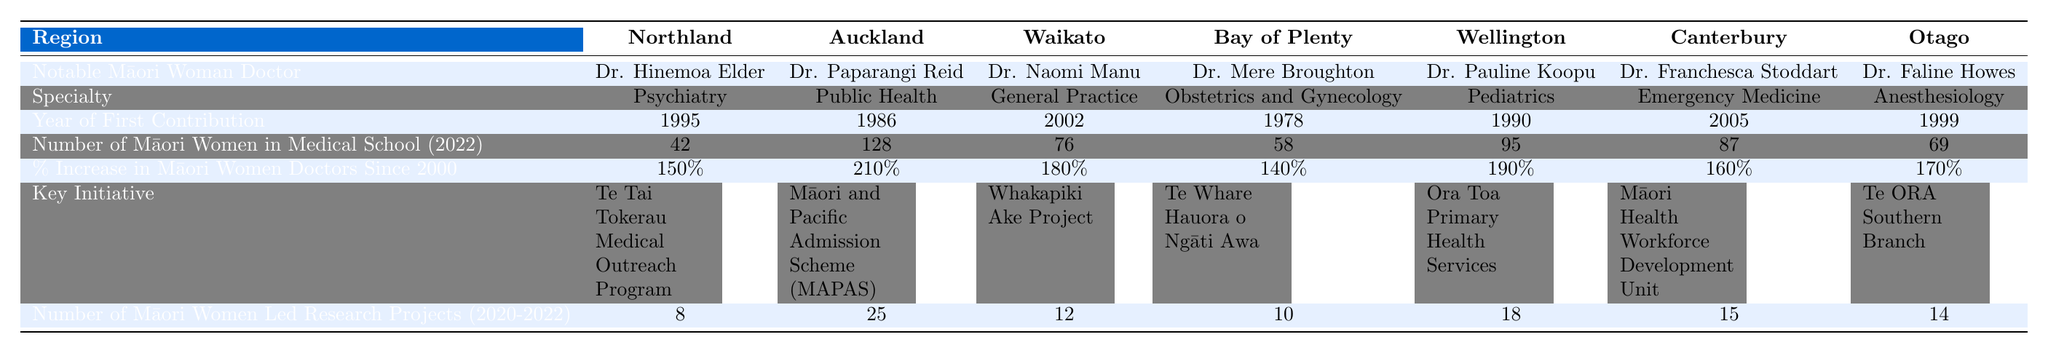What is the specialty of Dr. Faline Howes? According to the table, Dr. Faline Howes is listed under the "Specialty" row in the Otago region, which indicates her specialty is Anesthesiology.
Answer: Anesthesiology Which region has the highest percentage increase in Māori women doctors since 2000? In the table, the Percentage Increase in Māori Women Doctors Since 2000 for each region shows Auckland has the highest at 210%.
Answer: Auckland How many Māori women in medical school were there in Waikato in 2022? The table lists the Number of Māori Women in Medical School (2022) for Waikato, which is 76.
Answer: 76 What is the year of the first contribution of Dr. Mere Broughton? The table indicates that Dr. Mere Broughton's year of first contribution is recorded as 1978 under the relevant row.
Answer: 1978 What is the total number of Māori women led research projects reported from 2020-2022 across all regions? To find the total, we sum the values in the Number of Māori Women Led Research Projects (2020-2022) row: 8 + 25 + 12 + 10 + 18 + 15 + 14 = 102.
Answer: 102 Which region has the lowest number of Māori women in medical school in 2022? By comparing the values in the Number of Māori Women in Medical School (2022) row, Northland has the lowest with 42.
Answer: Northland Is there a notable Māori woman doctor specializing in Pediatrics? Examining the Specialty row, Dr. Pauline Koopu is identified as a notable Māori woman doctor in the specialty of Pediatrics. Thus, the answer is yes.
Answer: Yes How many more Māori women are in medical school in Auckland compared to Northland in 2022? The difference is calculated as the number of Māori women in Auckland (128) minus the number in Northland (42), resulting in 128 - 42 = 86.
Answer: 86 What is the key initiative associated with Dr. Naomi Manu's region? From the table, the key initiative associated with Waikato, where Dr. Naomi Manu is located, is the Whakapiki Ake Project.
Answer: Whakapiki Ake Project If we consider the average number of Māori women led research projects across all regions, what would it be? We can calculate the average by summing the projects (8 + 25 + 12 + 10 + 18 + 15 + 14 = 102) and dividing by the number of regions (7), resulting in 102 / 7 ≈ 14.57.
Answer: Approximately 14.57 